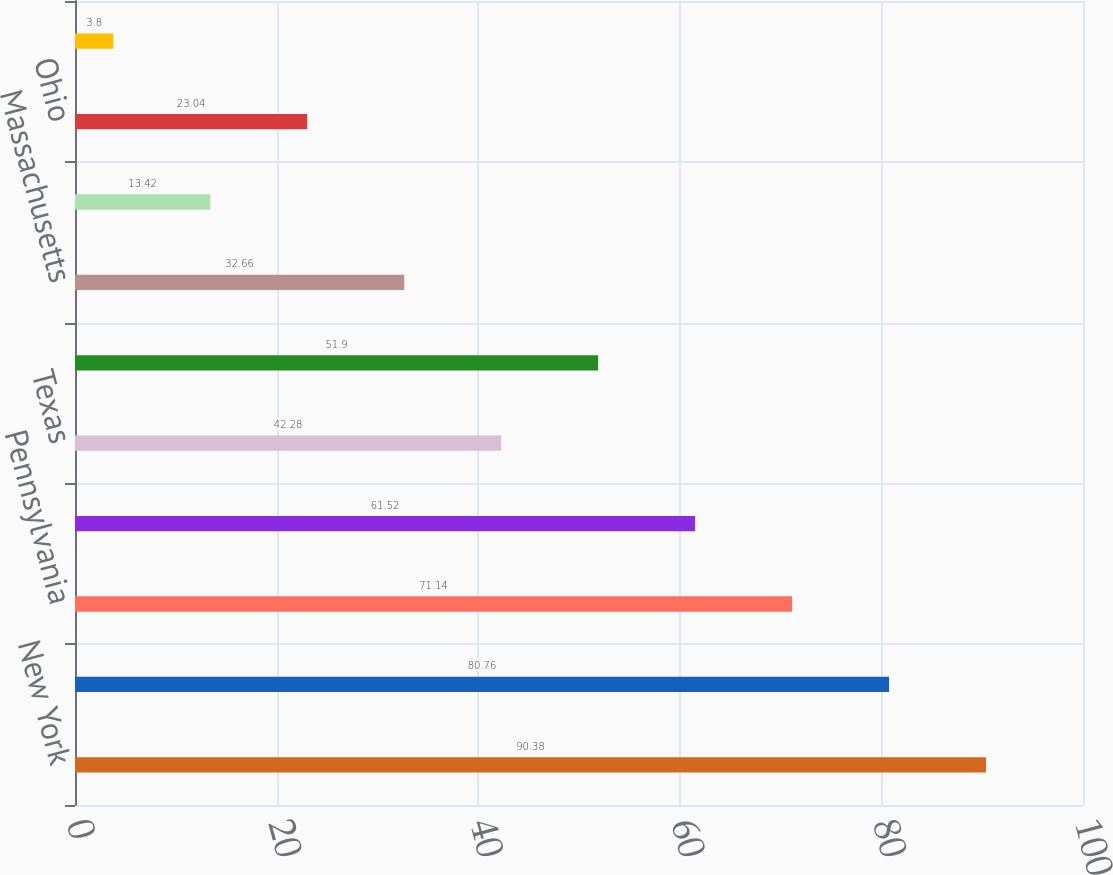<chart> <loc_0><loc_0><loc_500><loc_500><bar_chart><fcel>New York<fcel>California<fcel>Pennsylvania<fcel>Illinois<fcel>Texas<fcel>New Jersey<fcel>Massachusetts<fcel>Michigan<fcel>Ohio<fcel>Florida<nl><fcel>90.38<fcel>80.76<fcel>71.14<fcel>61.52<fcel>42.28<fcel>51.9<fcel>32.66<fcel>13.42<fcel>23.04<fcel>3.8<nl></chart> 